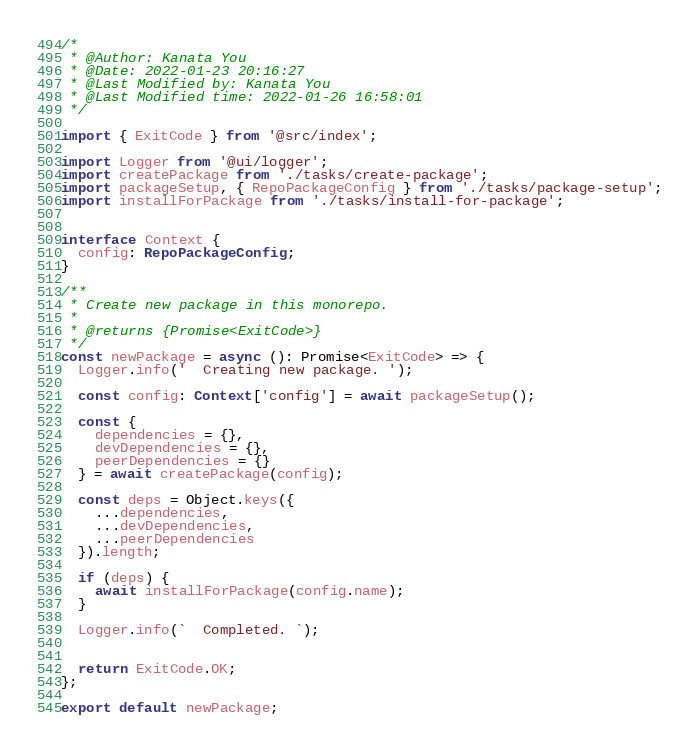Convert code to text. <code><loc_0><loc_0><loc_500><loc_500><_TypeScript_>/*
 * @Author: Kanata You 
 * @Date: 2022-01-23 20:16:27 
 * @Last Modified by: Kanata You
 * @Last Modified time: 2022-01-26 16:58:01
 */

import { ExitCode } from '@src/index';

import Logger from '@ui/logger';
import createPackage from './tasks/create-package';
import packageSetup, { RepoPackageConfig } from './tasks/package-setup';
import installForPackage from './tasks/install-for-package';


interface Context {
  config: RepoPackageConfig;
}

/**
 * Create new package in this monorepo.
 * 
 * @returns {Promise<ExitCode>}
 */
const newPackage = async (): Promise<ExitCode> => {
  Logger.info('  Creating new package. ');
  
  const config: Context['config'] = await packageSetup();

  const {
    dependencies = {},
    devDependencies = {},
    peerDependencies = {}
  } = await createPackage(config);

  const deps = Object.keys({
    ...dependencies,
    ...devDependencies,
    ...peerDependencies
  }).length;

  if (deps) {
    await installForPackage(config.name);
  }

  Logger.info(`  Completed. `);


  return ExitCode.OK;
};

export default newPackage;
</code> 